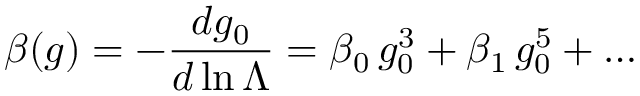Convert formula to latex. <formula><loc_0><loc_0><loc_500><loc_500>\beta ( g ) = - { \frac { d g _ { 0 } } { d \ln \Lambda } } = \beta _ { 0 } \, g _ { 0 } ^ { 3 } + \beta _ { 1 } \, g _ { 0 } ^ { 5 } + \dots</formula> 